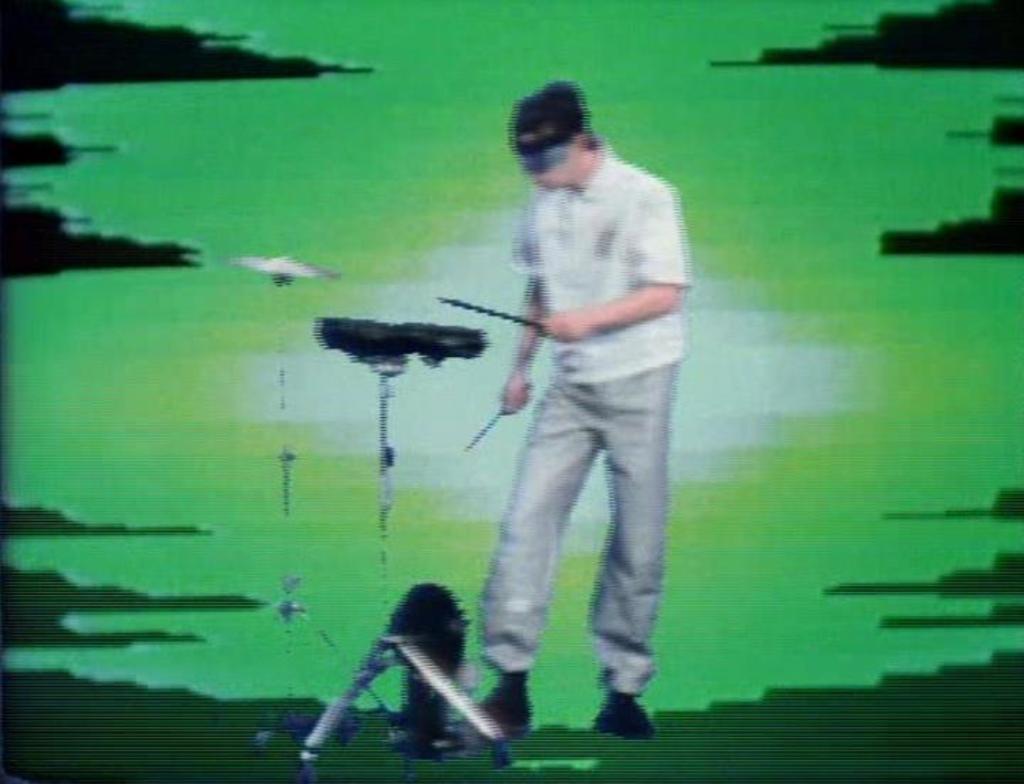Can you describe this image briefly? This image consists of a person. There is a musical instrument in front of him. He is wearing a white shirt. 